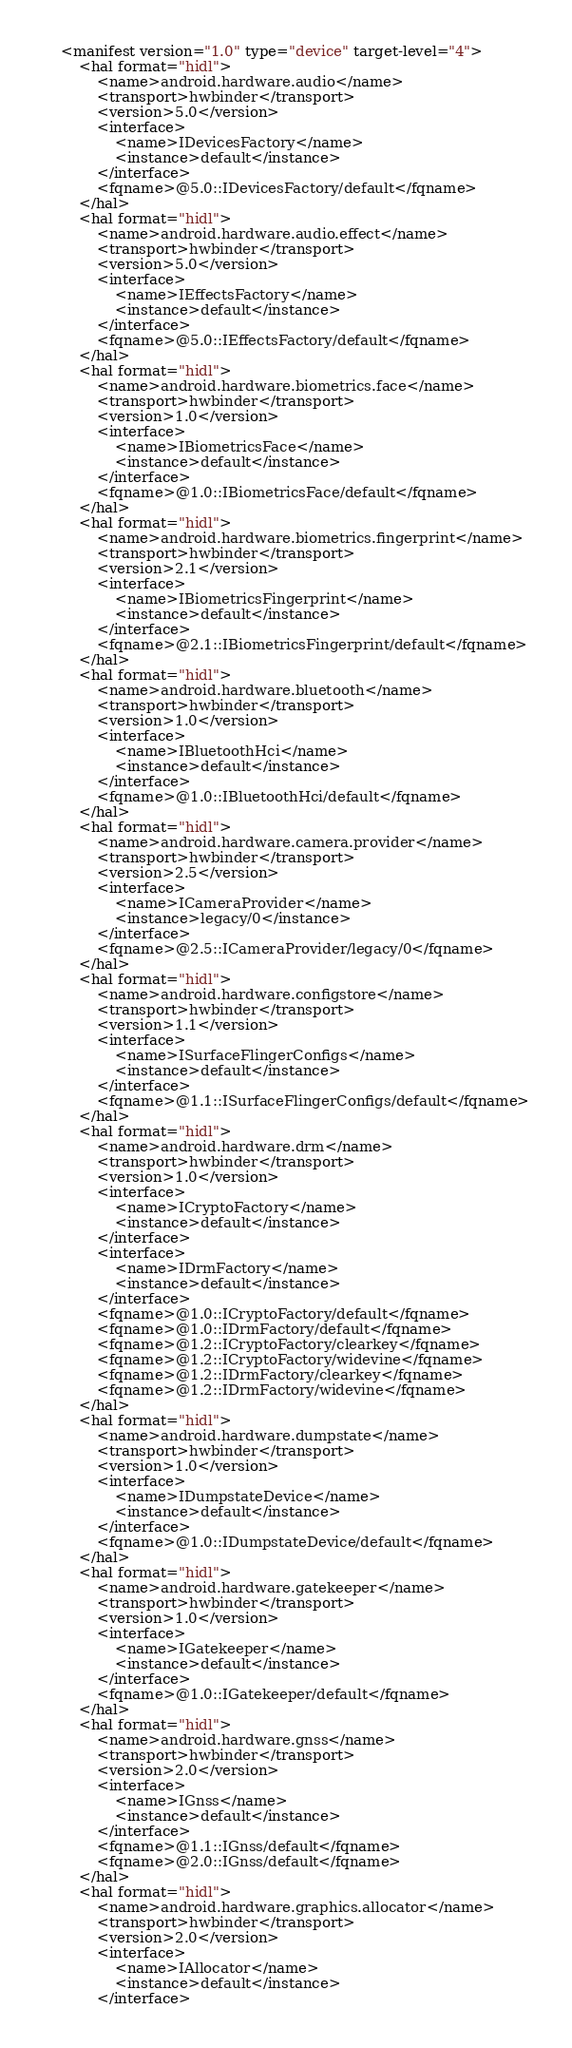<code> <loc_0><loc_0><loc_500><loc_500><_XML_><manifest version="1.0" type="device" target-level="4">
    <hal format="hidl">
        <name>android.hardware.audio</name>
        <transport>hwbinder</transport>
        <version>5.0</version>
        <interface>
            <name>IDevicesFactory</name>
            <instance>default</instance>
        </interface>
        <fqname>@5.0::IDevicesFactory/default</fqname>
    </hal>
    <hal format="hidl">
        <name>android.hardware.audio.effect</name>
        <transport>hwbinder</transport>
        <version>5.0</version>
        <interface>
            <name>IEffectsFactory</name>
            <instance>default</instance>
        </interface>
        <fqname>@5.0::IEffectsFactory/default</fqname>
    </hal>
    <hal format="hidl">
        <name>android.hardware.biometrics.face</name>
        <transport>hwbinder</transport>
        <version>1.0</version>
        <interface>
            <name>IBiometricsFace</name>
            <instance>default</instance>
        </interface>
        <fqname>@1.0::IBiometricsFace/default</fqname>
    </hal>
    <hal format="hidl">
        <name>android.hardware.biometrics.fingerprint</name>
        <transport>hwbinder</transport>
        <version>2.1</version>
        <interface>
            <name>IBiometricsFingerprint</name>
            <instance>default</instance>
        </interface>
        <fqname>@2.1::IBiometricsFingerprint/default</fqname>
    </hal>
    <hal format="hidl">
        <name>android.hardware.bluetooth</name>
        <transport>hwbinder</transport>
        <version>1.0</version>
        <interface>
            <name>IBluetoothHci</name>
            <instance>default</instance>
        </interface>
        <fqname>@1.0::IBluetoothHci/default</fqname>
    </hal>
    <hal format="hidl">
        <name>android.hardware.camera.provider</name>
        <transport>hwbinder</transport>
        <version>2.5</version>
        <interface>
            <name>ICameraProvider</name>
            <instance>legacy/0</instance>
        </interface>
        <fqname>@2.5::ICameraProvider/legacy/0</fqname>
    </hal>
    <hal format="hidl">
        <name>android.hardware.configstore</name>
        <transport>hwbinder</transport>
        <version>1.1</version>
        <interface>
            <name>ISurfaceFlingerConfigs</name>
            <instance>default</instance>
        </interface>
        <fqname>@1.1::ISurfaceFlingerConfigs/default</fqname>
    </hal>
    <hal format="hidl">
        <name>android.hardware.drm</name>
        <transport>hwbinder</transport>
        <version>1.0</version>
        <interface>
            <name>ICryptoFactory</name>
            <instance>default</instance>
        </interface>
        <interface>
            <name>IDrmFactory</name>
            <instance>default</instance>
        </interface>
        <fqname>@1.0::ICryptoFactory/default</fqname>
        <fqname>@1.0::IDrmFactory/default</fqname>
        <fqname>@1.2::ICryptoFactory/clearkey</fqname>
        <fqname>@1.2::ICryptoFactory/widevine</fqname>
        <fqname>@1.2::IDrmFactory/clearkey</fqname>
        <fqname>@1.2::IDrmFactory/widevine</fqname>
    </hal>
    <hal format="hidl">
        <name>android.hardware.dumpstate</name>
        <transport>hwbinder</transport>
        <version>1.0</version>
        <interface>
            <name>IDumpstateDevice</name>
            <instance>default</instance>
        </interface>
        <fqname>@1.0::IDumpstateDevice/default</fqname>
    </hal>
    <hal format="hidl">
        <name>android.hardware.gatekeeper</name>
        <transport>hwbinder</transport>
        <version>1.0</version>
        <interface>
            <name>IGatekeeper</name>
            <instance>default</instance>
        </interface>
        <fqname>@1.0::IGatekeeper/default</fqname>
    </hal>
    <hal format="hidl">
        <name>android.hardware.gnss</name>
        <transport>hwbinder</transport>
        <version>2.0</version>
        <interface>
            <name>IGnss</name>
            <instance>default</instance>
        </interface>
        <fqname>@1.1::IGnss/default</fqname>
        <fqname>@2.0::IGnss/default</fqname>
    </hal>
    <hal format="hidl">
        <name>android.hardware.graphics.allocator</name>
        <transport>hwbinder</transport>
        <version>2.0</version>
        <interface>
            <name>IAllocator</name>
            <instance>default</instance>
        </interface></code> 